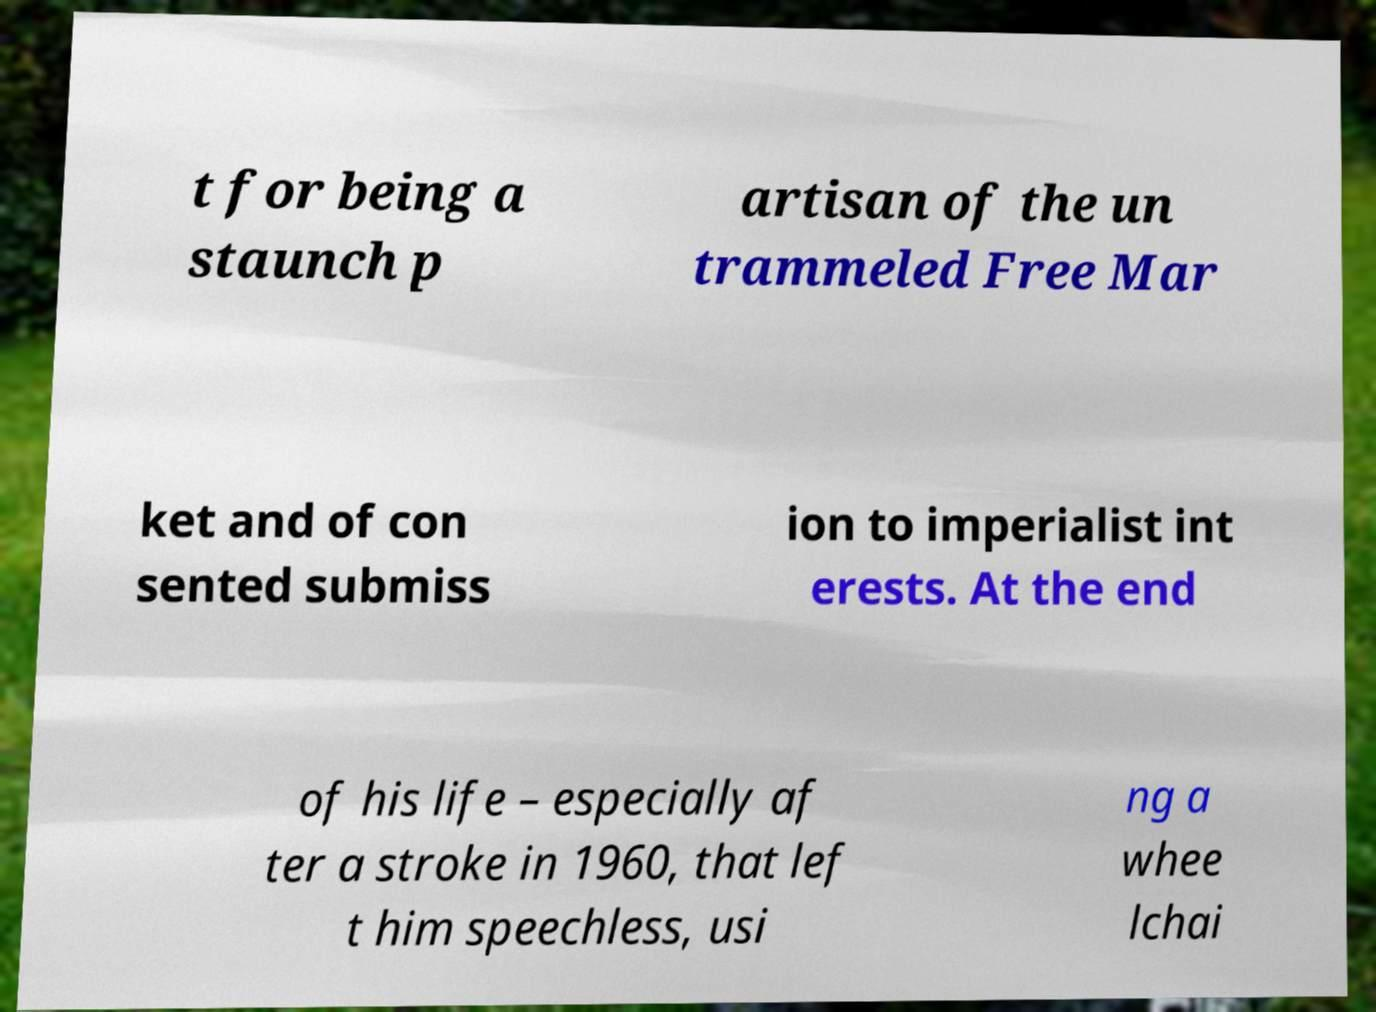There's text embedded in this image that I need extracted. Can you transcribe it verbatim? t for being a staunch p artisan of the un trammeled Free Mar ket and of con sented submiss ion to imperialist int erests. At the end of his life – especially af ter a stroke in 1960, that lef t him speechless, usi ng a whee lchai 